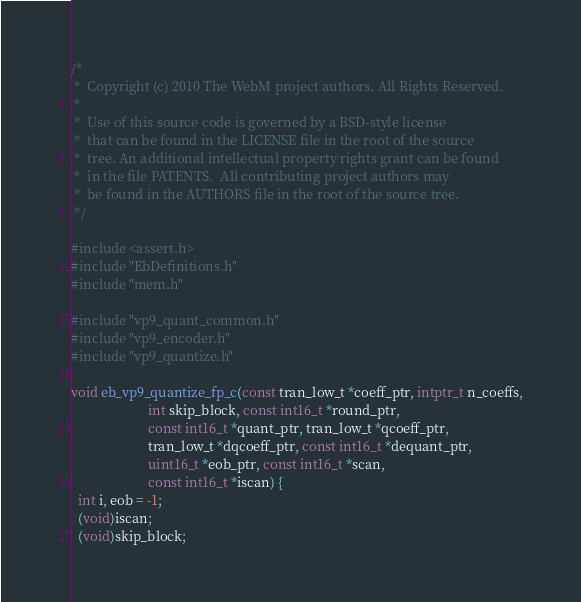Convert code to text. <code><loc_0><loc_0><loc_500><loc_500><_C_>/*
 *  Copyright (c) 2010 The WebM project authors. All Rights Reserved.
 *
 *  Use of this source code is governed by a BSD-style license
 *  that can be found in the LICENSE file in the root of the source
 *  tree. An additional intellectual property rights grant can be found
 *  in the file PATENTS.  All contributing project authors may
 *  be found in the AUTHORS file in the root of the source tree.
 */

#include <assert.h>
#include "EbDefinitions.h"
#include "mem.h"

#include "vp9_quant_common.h"
#include "vp9_encoder.h"
#include "vp9_quantize.h"

void eb_vp9_quantize_fp_c(const tran_low_t *coeff_ptr, intptr_t n_coeffs,
                       int skip_block, const int16_t *round_ptr,
                       const int16_t *quant_ptr, tran_low_t *qcoeff_ptr,
                       tran_low_t *dqcoeff_ptr, const int16_t *dequant_ptr,
                       uint16_t *eob_ptr, const int16_t *scan,
                       const int16_t *iscan) {
  int i, eob = -1;
  (void)iscan;
  (void)skip_block;</code> 